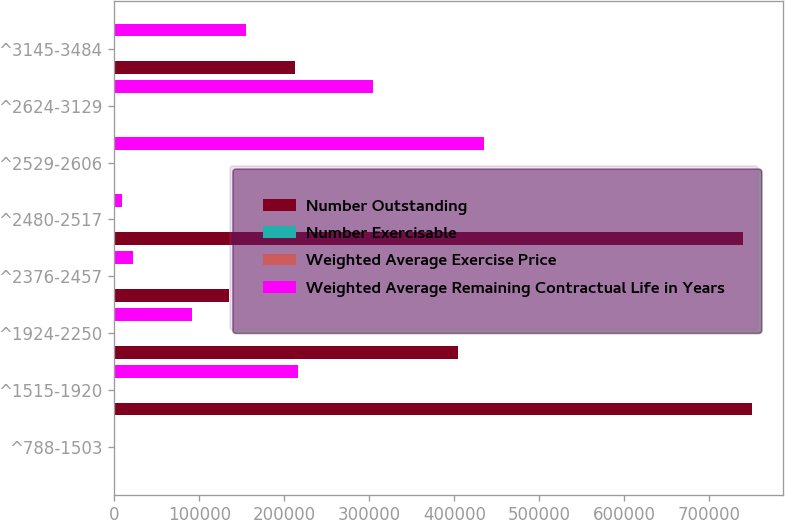Convert chart. <chart><loc_0><loc_0><loc_500><loc_500><stacked_bar_chart><ecel><fcel>^788-1503<fcel>^1515-1920<fcel>^1924-2250<fcel>^2376-2457<fcel>^2480-2517<fcel>^2529-2606<fcel>^2624-3129<fcel>^3145-3484<nl><fcel>Number Outstanding<fcel>28.3<fcel>749958<fcel>404625<fcel>134500<fcel>739575<fcel>28.3<fcel>28.3<fcel>212475<nl><fcel>Number Exercisable<fcel>4.26<fcel>8.1<fcel>8.27<fcel>6.78<fcel>4.55<fcel>7.54<fcel>7.92<fcel>6.75<nl><fcel>Weighted Average Exercise Price<fcel>10.73<fcel>16.96<fcel>21.63<fcel>24.36<fcel>25.15<fcel>26.01<fcel>30.59<fcel>33.12<nl><fcel>Weighted Average Remaining Contractual Life in Years<fcel>28.3<fcel>215500<fcel>90876<fcel>21376<fcel>8625<fcel>435064<fcel>304013<fcel>155325<nl></chart> 